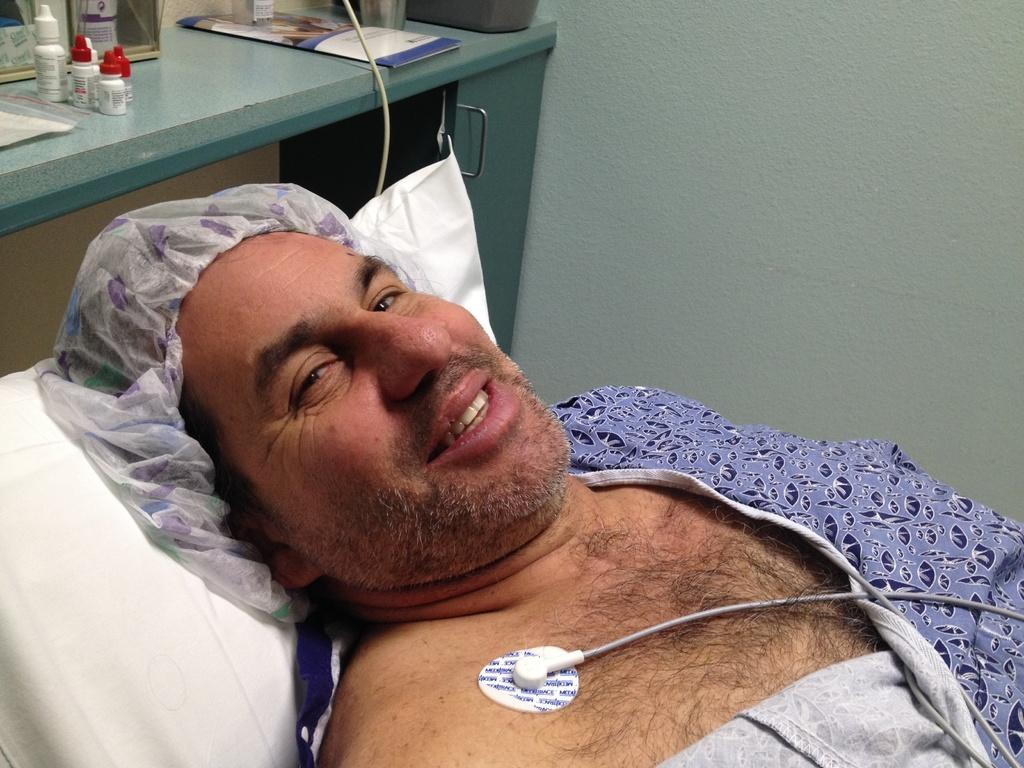What is the person in the image doing? The person is lying on a pillow in the image. What can be seen in the image besides the person? There is a table in the image. What is on the table? There are many objects on the table. What is visible in the background of the image? There is a wall in the background of the image. Are there any ants crawling on the person in the image? There is no indication of ants in the image; the focus is on the person lying on a pillow and the surrounding environment. 